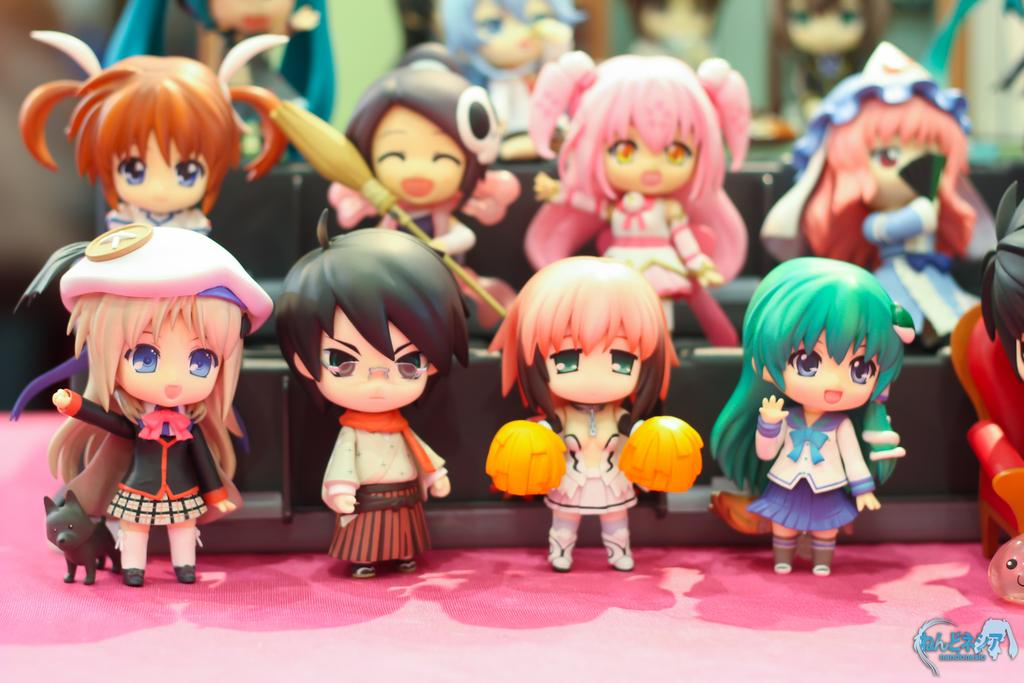What type of objects are present on the table in the image? There are toy dolls or figurines in the image. What is the table's appearance in the image? The table is covered with a pink cloth. Can you describe the background of the image? The background of the image is blurred. What flavor of ice cream is being served on the table in the image? There is no ice cream present in the image; it only features toy dolls or figurines on a table covered with a pink cloth. 